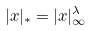Convert formula to latex. <formula><loc_0><loc_0><loc_500><loc_500>| x | _ { * } = | x | _ { \infty } ^ { \lambda }</formula> 